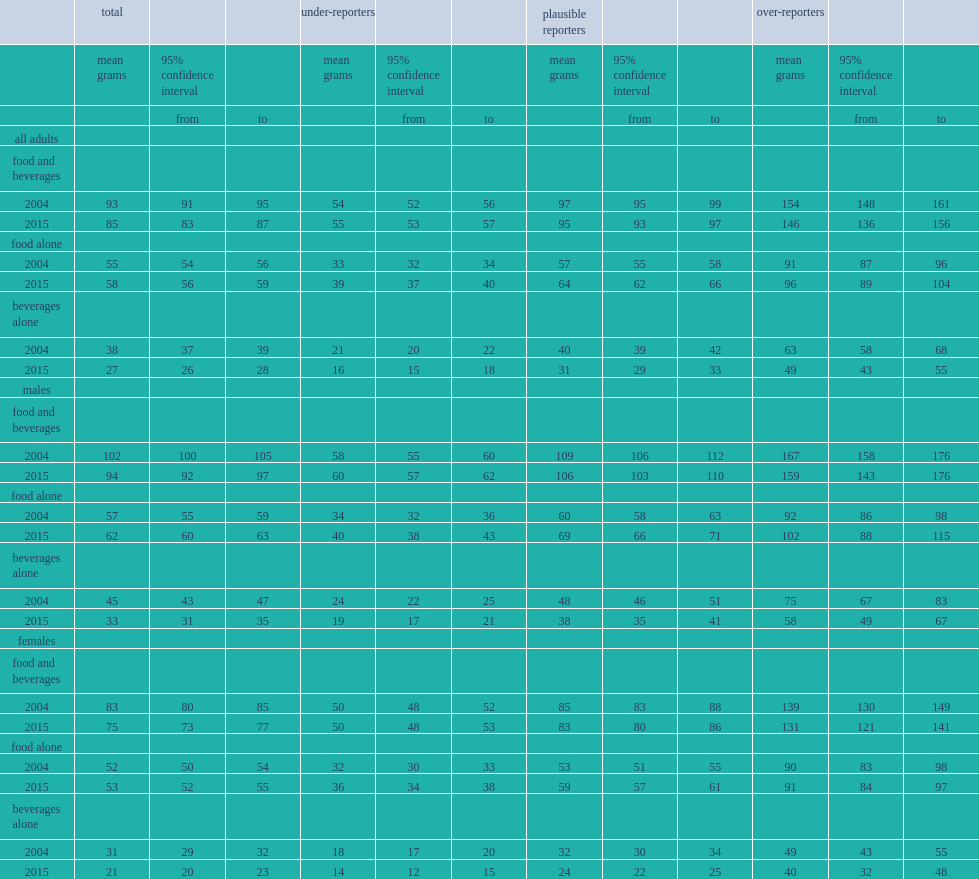How many grams of total sugars did canadian aged 19 and older report comsuming in 2015? 85. How many grams of total sugar did plausible reporters consume? 95. What is the proportion of sugars from beverages in 2015? 0.317647. Which year has a higher average daily total sugars intakes from food alone? 2015.0. Which year has a lower average total sugars intakes from beverages alone for all adults,male and female, regardless of misrporting status? 2015.0. 